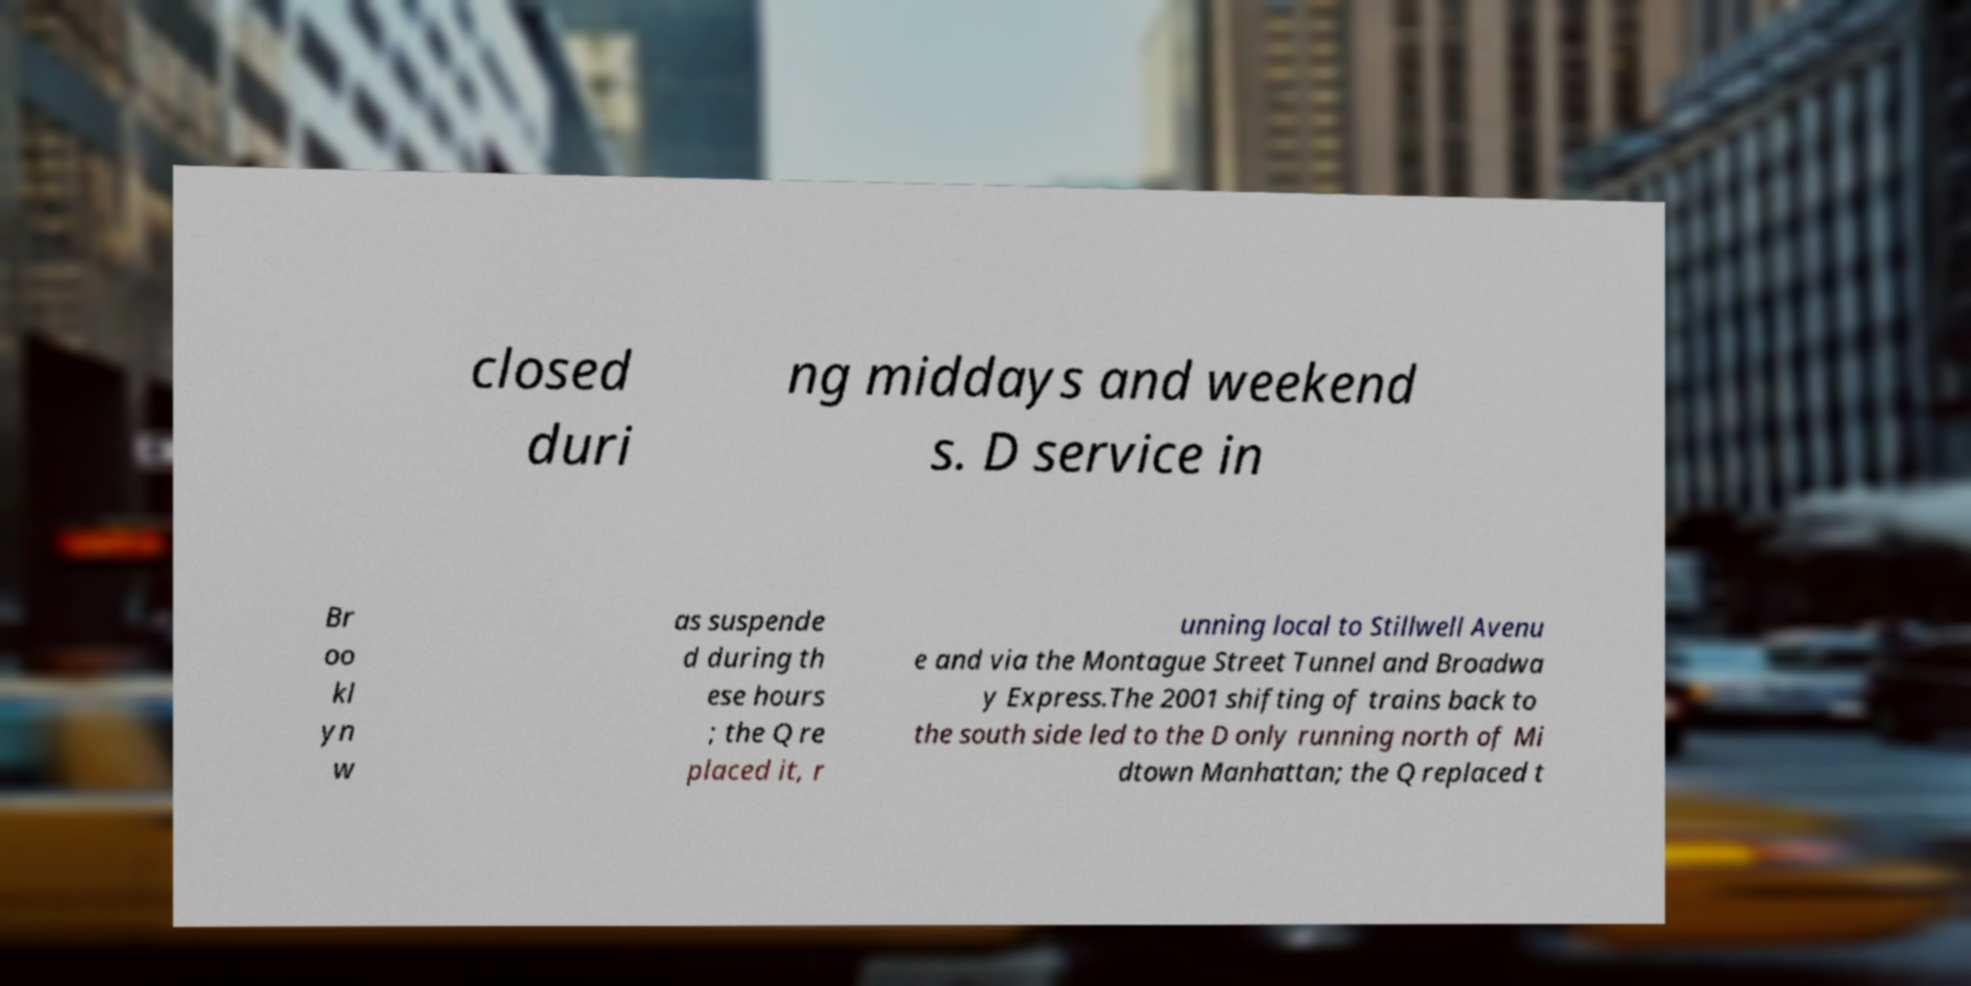Please read and relay the text visible in this image. What does it say? closed duri ng middays and weekend s. D service in Br oo kl yn w as suspende d during th ese hours ; the Q re placed it, r unning local to Stillwell Avenu e and via the Montague Street Tunnel and Broadwa y Express.The 2001 shifting of trains back to the south side led to the D only running north of Mi dtown Manhattan; the Q replaced t 